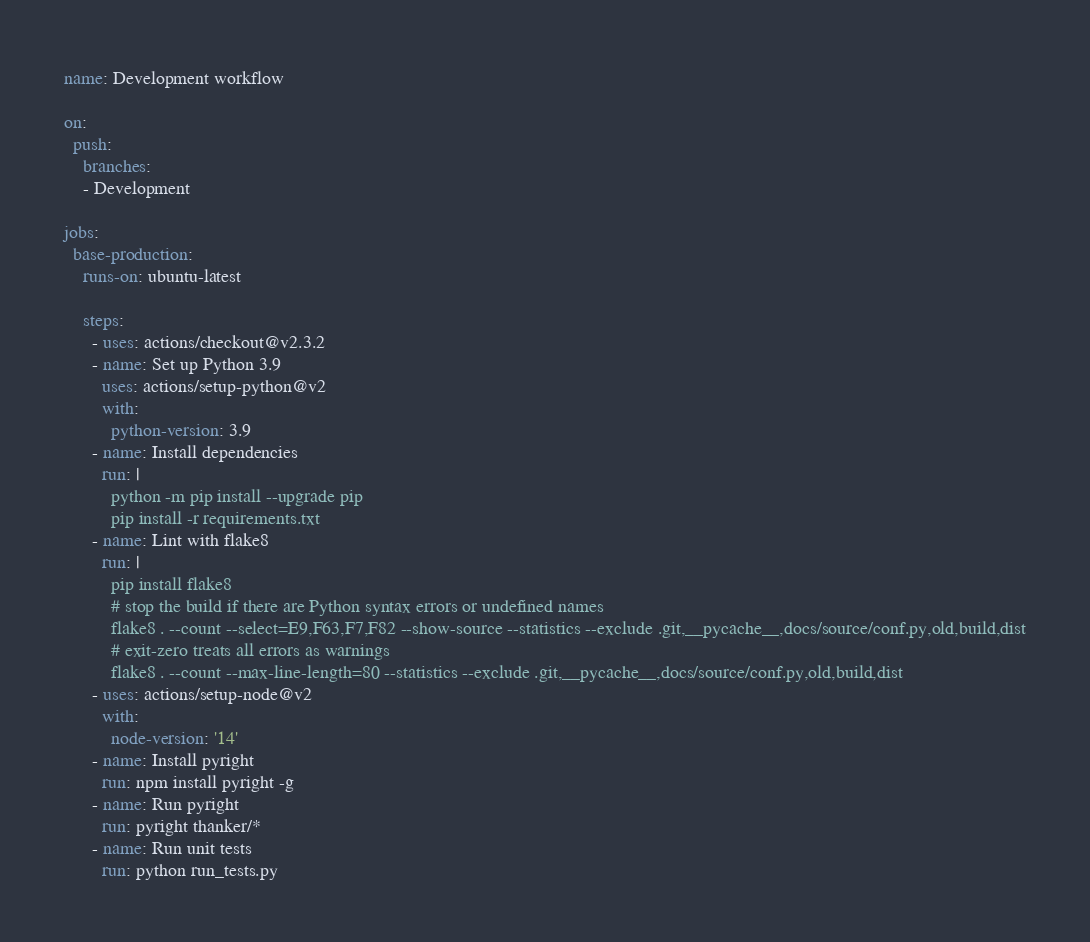<code> <loc_0><loc_0><loc_500><loc_500><_YAML_>name: Development workflow

on:
  push:
    branches:
    - Development

jobs:
  base-production:
    runs-on: ubuntu-latest

    steps:
      - uses: actions/checkout@v2.3.2
      - name: Set up Python 3.9
        uses: actions/setup-python@v2
        with:
          python-version: 3.9
      - name: Install dependencies
        run: |
          python -m pip install --upgrade pip
          pip install -r requirements.txt
      - name: Lint with flake8
        run: |
          pip install flake8
          # stop the build if there are Python syntax errors or undefined names
          flake8 . --count --select=E9,F63,F7,F82 --show-source --statistics --exclude .git,__pycache__,docs/source/conf.py,old,build,dist
          # exit-zero treats all errors as warnings
          flake8 . --count --max-line-length=80 --statistics --exclude .git,__pycache__,docs/source/conf.py,old,build,dist
      - uses: actions/setup-node@v2
        with:
          node-version: '14'
      - name: Install pyright
        run: npm install pyright -g
      - name: Run pyright
        run: pyright thanker/*
      - name: Run unit tests
        run: python run_tests.py</code> 